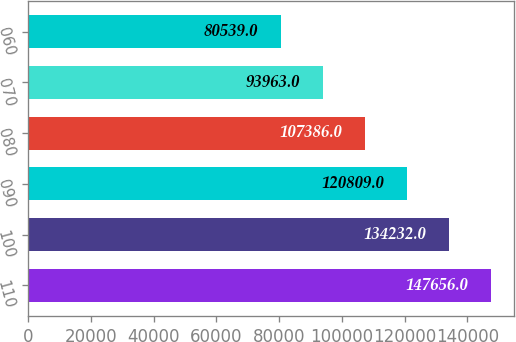Convert chart to OTSL. <chart><loc_0><loc_0><loc_500><loc_500><bar_chart><fcel>110<fcel>100<fcel>090<fcel>080<fcel>070<fcel>060<nl><fcel>147656<fcel>134232<fcel>120809<fcel>107386<fcel>93963<fcel>80539<nl></chart> 